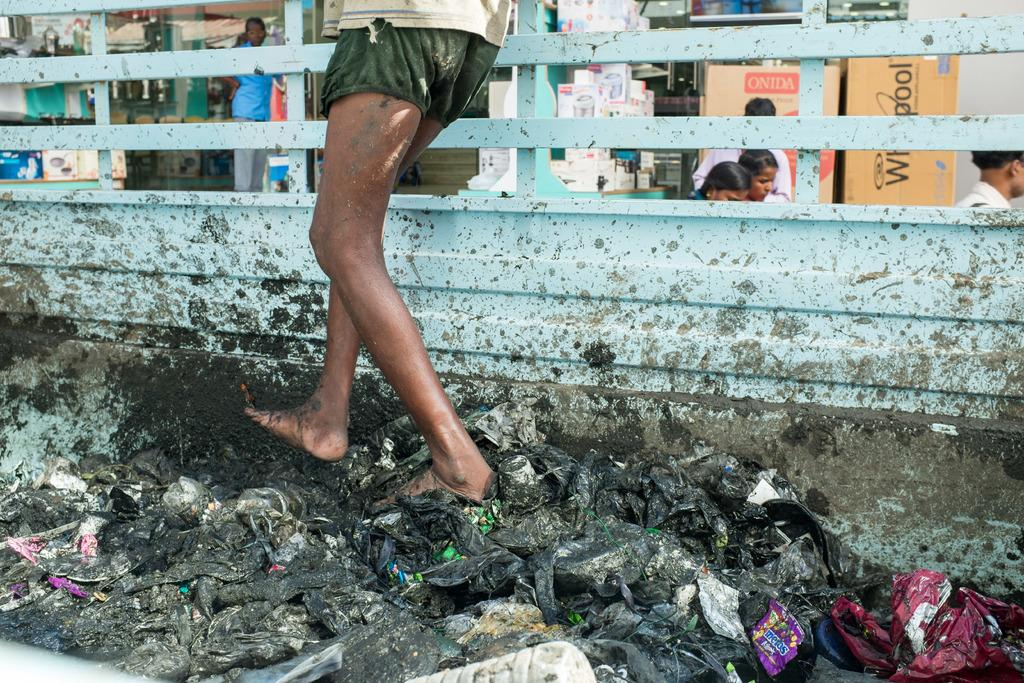What is the man in the image doing? The man is standing on a vehicle in the image. What can be seen in the background of the image? There are people and other things visible in the background of the image. What type of waves can be seen crashing on the shore in the image? There are no waves or shore visible in the image; it features a man standing on a vehicle with people and other things in the background. 